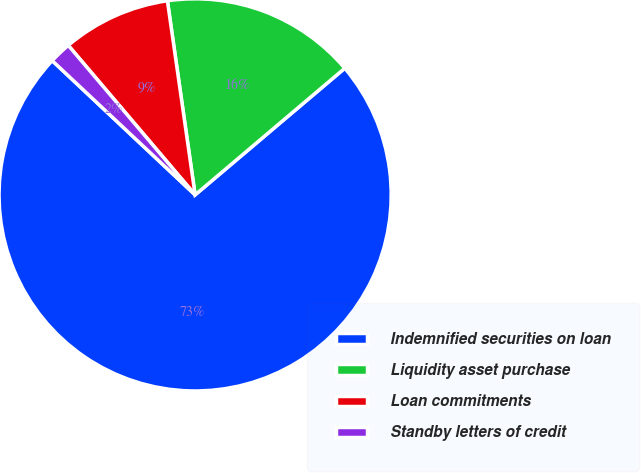Convert chart to OTSL. <chart><loc_0><loc_0><loc_500><loc_500><pie_chart><fcel>Indemnified securities on loan<fcel>Liquidity asset purchase<fcel>Loan commitments<fcel>Standby letters of credit<nl><fcel>73.18%<fcel>16.08%<fcel>8.94%<fcel>1.8%<nl></chart> 